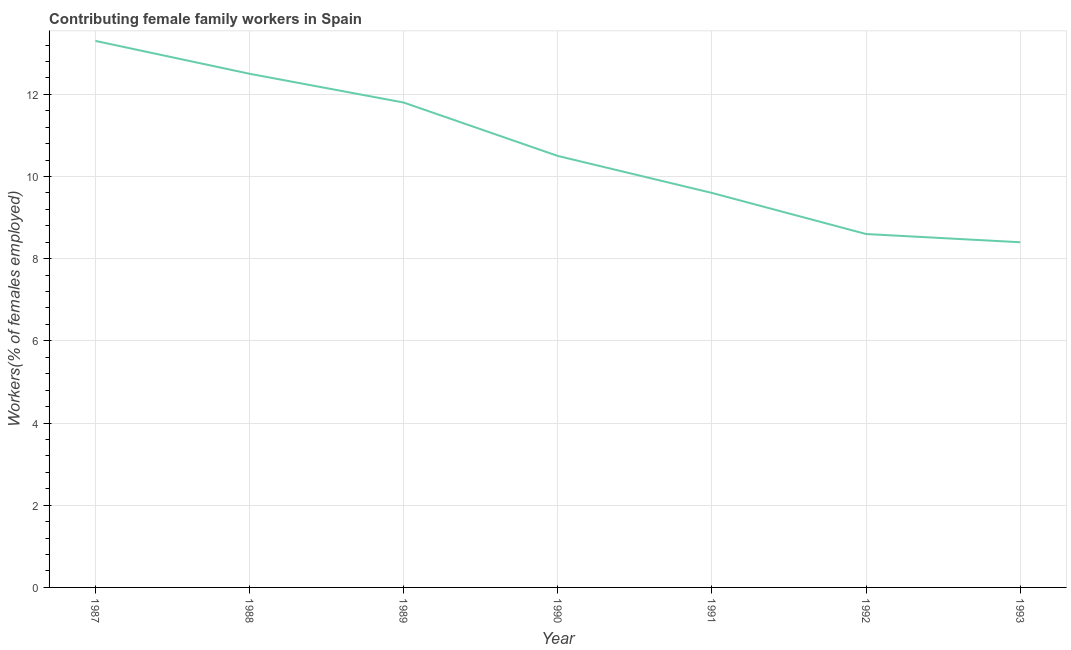What is the contributing female family workers in 1987?
Provide a succinct answer. 13.3. Across all years, what is the maximum contributing female family workers?
Make the answer very short. 13.3. Across all years, what is the minimum contributing female family workers?
Keep it short and to the point. 8.4. In which year was the contributing female family workers minimum?
Your answer should be compact. 1993. What is the sum of the contributing female family workers?
Your answer should be very brief. 74.7. What is the difference between the contributing female family workers in 1991 and 1993?
Make the answer very short. 1.2. What is the average contributing female family workers per year?
Keep it short and to the point. 10.67. Do a majority of the years between 1990 and 1987 (inclusive) have contributing female family workers greater than 11.6 %?
Offer a terse response. Yes. What is the ratio of the contributing female family workers in 1989 to that in 1990?
Provide a short and direct response. 1.12. Is the contributing female family workers in 1991 less than that in 1993?
Make the answer very short. No. What is the difference between the highest and the second highest contributing female family workers?
Provide a short and direct response. 0.8. Is the sum of the contributing female family workers in 1988 and 1992 greater than the maximum contributing female family workers across all years?
Make the answer very short. Yes. What is the difference between the highest and the lowest contributing female family workers?
Offer a very short reply. 4.9. How many lines are there?
Offer a very short reply. 1. Does the graph contain grids?
Offer a terse response. Yes. What is the title of the graph?
Provide a short and direct response. Contributing female family workers in Spain. What is the label or title of the X-axis?
Give a very brief answer. Year. What is the label or title of the Y-axis?
Provide a succinct answer. Workers(% of females employed). What is the Workers(% of females employed) in 1987?
Give a very brief answer. 13.3. What is the Workers(% of females employed) of 1989?
Ensure brevity in your answer.  11.8. What is the Workers(% of females employed) in 1990?
Make the answer very short. 10.5. What is the Workers(% of females employed) in 1991?
Offer a terse response. 9.6. What is the Workers(% of females employed) of 1992?
Keep it short and to the point. 8.6. What is the Workers(% of females employed) in 1993?
Your answer should be compact. 8.4. What is the difference between the Workers(% of females employed) in 1987 and 1989?
Keep it short and to the point. 1.5. What is the difference between the Workers(% of females employed) in 1987 and 1990?
Provide a short and direct response. 2.8. What is the difference between the Workers(% of females employed) in 1987 and 1992?
Your answer should be very brief. 4.7. What is the difference between the Workers(% of females employed) in 1988 and 1990?
Keep it short and to the point. 2. What is the difference between the Workers(% of females employed) in 1988 and 1991?
Make the answer very short. 2.9. What is the difference between the Workers(% of females employed) in 1988 and 1992?
Offer a terse response. 3.9. What is the difference between the Workers(% of females employed) in 1988 and 1993?
Your response must be concise. 4.1. What is the difference between the Workers(% of females employed) in 1989 and 1992?
Offer a very short reply. 3.2. What is the difference between the Workers(% of females employed) in 1990 and 1991?
Provide a short and direct response. 0.9. What is the difference between the Workers(% of females employed) in 1990 and 1992?
Make the answer very short. 1.9. What is the difference between the Workers(% of females employed) in 1990 and 1993?
Keep it short and to the point. 2.1. What is the difference between the Workers(% of females employed) in 1992 and 1993?
Offer a terse response. 0.2. What is the ratio of the Workers(% of females employed) in 1987 to that in 1988?
Offer a terse response. 1.06. What is the ratio of the Workers(% of females employed) in 1987 to that in 1989?
Provide a succinct answer. 1.13. What is the ratio of the Workers(% of females employed) in 1987 to that in 1990?
Provide a short and direct response. 1.27. What is the ratio of the Workers(% of females employed) in 1987 to that in 1991?
Ensure brevity in your answer.  1.39. What is the ratio of the Workers(% of females employed) in 1987 to that in 1992?
Your response must be concise. 1.55. What is the ratio of the Workers(% of females employed) in 1987 to that in 1993?
Offer a terse response. 1.58. What is the ratio of the Workers(% of females employed) in 1988 to that in 1989?
Your answer should be compact. 1.06. What is the ratio of the Workers(% of females employed) in 1988 to that in 1990?
Your response must be concise. 1.19. What is the ratio of the Workers(% of females employed) in 1988 to that in 1991?
Offer a very short reply. 1.3. What is the ratio of the Workers(% of females employed) in 1988 to that in 1992?
Ensure brevity in your answer.  1.45. What is the ratio of the Workers(% of females employed) in 1988 to that in 1993?
Your answer should be very brief. 1.49. What is the ratio of the Workers(% of females employed) in 1989 to that in 1990?
Make the answer very short. 1.12. What is the ratio of the Workers(% of females employed) in 1989 to that in 1991?
Offer a terse response. 1.23. What is the ratio of the Workers(% of females employed) in 1989 to that in 1992?
Ensure brevity in your answer.  1.37. What is the ratio of the Workers(% of females employed) in 1989 to that in 1993?
Provide a succinct answer. 1.41. What is the ratio of the Workers(% of females employed) in 1990 to that in 1991?
Provide a succinct answer. 1.09. What is the ratio of the Workers(% of females employed) in 1990 to that in 1992?
Give a very brief answer. 1.22. What is the ratio of the Workers(% of females employed) in 1991 to that in 1992?
Give a very brief answer. 1.12. What is the ratio of the Workers(% of females employed) in 1991 to that in 1993?
Make the answer very short. 1.14. What is the ratio of the Workers(% of females employed) in 1992 to that in 1993?
Make the answer very short. 1.02. 